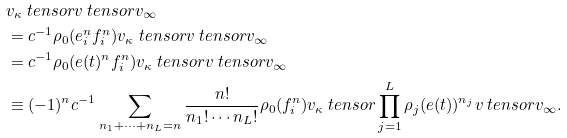Convert formula to latex. <formula><loc_0><loc_0><loc_500><loc_500>& v _ { \kappa } \ t e n s o r v \ t e n s o r v _ { \infty } \\ & = c ^ { - 1 } \rho _ { 0 } ( e _ { i } ^ { n } f _ { i } ^ { n } ) v _ { \kappa } \ t e n s o r v \ t e n s o r v _ { \infty } \\ & = c ^ { - 1 } \rho _ { 0 } ( e ( t ) ^ { n } f _ { i } ^ { n } ) v _ { \kappa } \ t e n s o r v \ t e n s o r v _ { \infty } \\ & \equiv ( - 1 ) ^ { n } c ^ { - 1 } \sum _ { n _ { 1 } + \cdots + n _ { L } = n } \frac { n ! } { n _ { 1 } ! \cdots n _ { L } ! } \rho _ { 0 } ( f _ { i } ^ { n } ) v _ { \kappa } \ t e n s o r \prod _ { j = 1 } ^ { L } \rho _ { j } ( e ( t ) ) ^ { n _ { j } } v \ t e n s o r v _ { \infty } .</formula> 